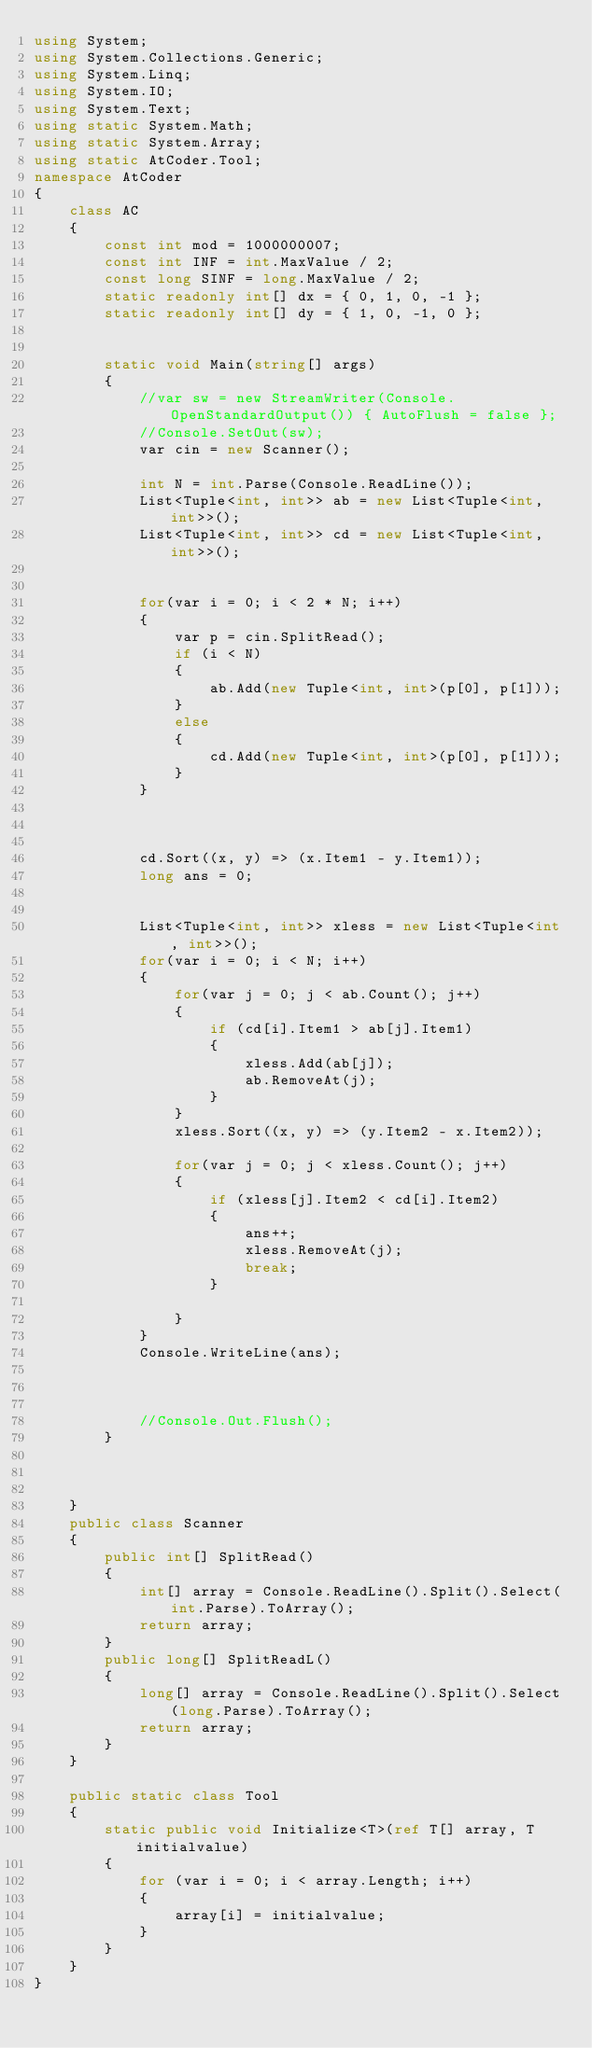Convert code to text. <code><loc_0><loc_0><loc_500><loc_500><_C#_>using System;
using System.Collections.Generic;
using System.Linq;
using System.IO;
using System.Text;
using static System.Math;
using static System.Array;
using static AtCoder.Tool;
namespace AtCoder
{
    class AC
    {
        const int mod = 1000000007;
        const int INF = int.MaxValue / 2;
        const long SINF = long.MaxValue / 2;
        static readonly int[] dx = { 0, 1, 0, -1 };
        static readonly int[] dy = { 1, 0, -1, 0 };
        

        static void Main(string[] args)
        {
            //var sw = new StreamWriter(Console.OpenStandardOutput()) { AutoFlush = false };
            //Console.SetOut(sw);
            var cin = new Scanner();

            int N = int.Parse(Console.ReadLine());
            List<Tuple<int, int>> ab = new List<Tuple<int, int>>();
            List<Tuple<int, int>> cd = new List<Tuple<int, int>>();
            

            for(var i = 0; i < 2 * N; i++)
            {
                var p = cin.SplitRead();
                if (i < N)
                {
                    ab.Add(new Tuple<int, int>(p[0], p[1]));
                }
                else
                {
                    cd.Add(new Tuple<int, int>(p[0], p[1]));
                }
            }



            cd.Sort((x, y) => (x.Item1 - y.Item1));
            long ans = 0;

            
            List<Tuple<int, int>> xless = new List<Tuple<int, int>>();
            for(var i = 0; i < N; i++)
            {
                for(var j = 0; j < ab.Count(); j++)
                {
                    if (cd[i].Item1 > ab[j].Item1)
                    {
                        xless.Add(ab[j]);
                        ab.RemoveAt(j);
                    }
                }
                xless.Sort((x, y) => (y.Item2 - x.Item2));
               
                for(var j = 0; j < xless.Count(); j++)
                {
                    if (xless[j].Item2 < cd[i].Item2)
                    {
                        ans++;
                        xless.RemoveAt(j);
                        break;
                    }

                }
            }
            Console.WriteLine(ans);



            //Console.Out.Flush();
        }
        
        
        
    }
    public class Scanner
    {
        public int[] SplitRead()
        {
            int[] array = Console.ReadLine().Split().Select(int.Parse).ToArray();
            return array;
        }
        public long[] SplitReadL()
        {
            long[] array = Console.ReadLine().Split().Select(long.Parse).ToArray();
            return array;
        }
    }

    public static class Tool
    {
        static public void Initialize<T>(ref T[] array, T initialvalue)
        {
            for (var i = 0; i < array.Length; i++)
            {
                array[i] = initialvalue;
            }
        }
    }
}
</code> 